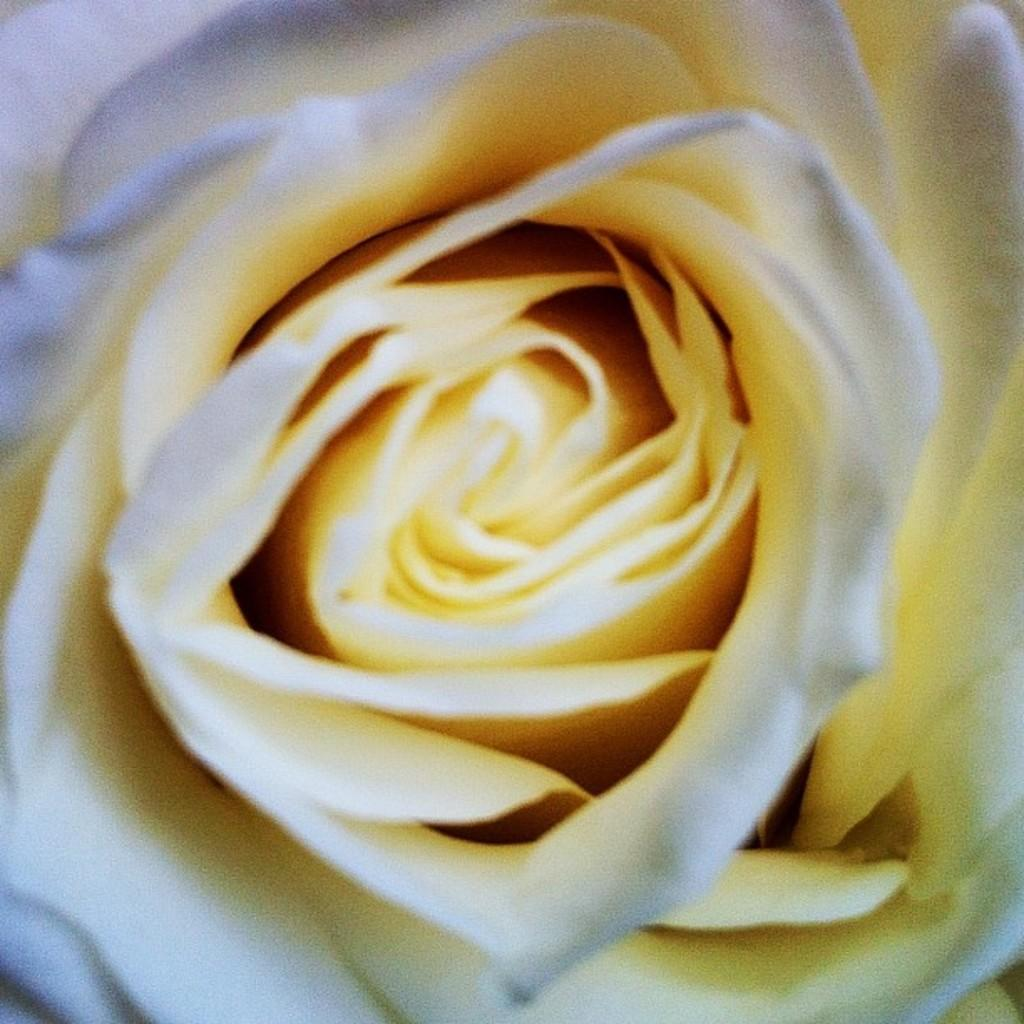What is the main subject of the image? The main subject of the image is a flower. Can you describe the colors of the flower? The flower has white and yellow colors. What type of cemetery can be seen in the background of the image? There is no cemetery present in the image; it only features a flower with white and yellow colors. 